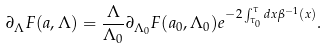Convert formula to latex. <formula><loc_0><loc_0><loc_500><loc_500>\partial _ { \Lambda } F ( a , \Lambda ) = \frac { \Lambda } { \Lambda _ { 0 } } \partial _ { \Lambda _ { 0 } } F ( a _ { 0 } , \Lambda _ { 0 } ) e ^ { - 2 \int _ { \tau _ { 0 } } ^ { \tau } d x \beta ^ { - 1 } ( x ) } .</formula> 